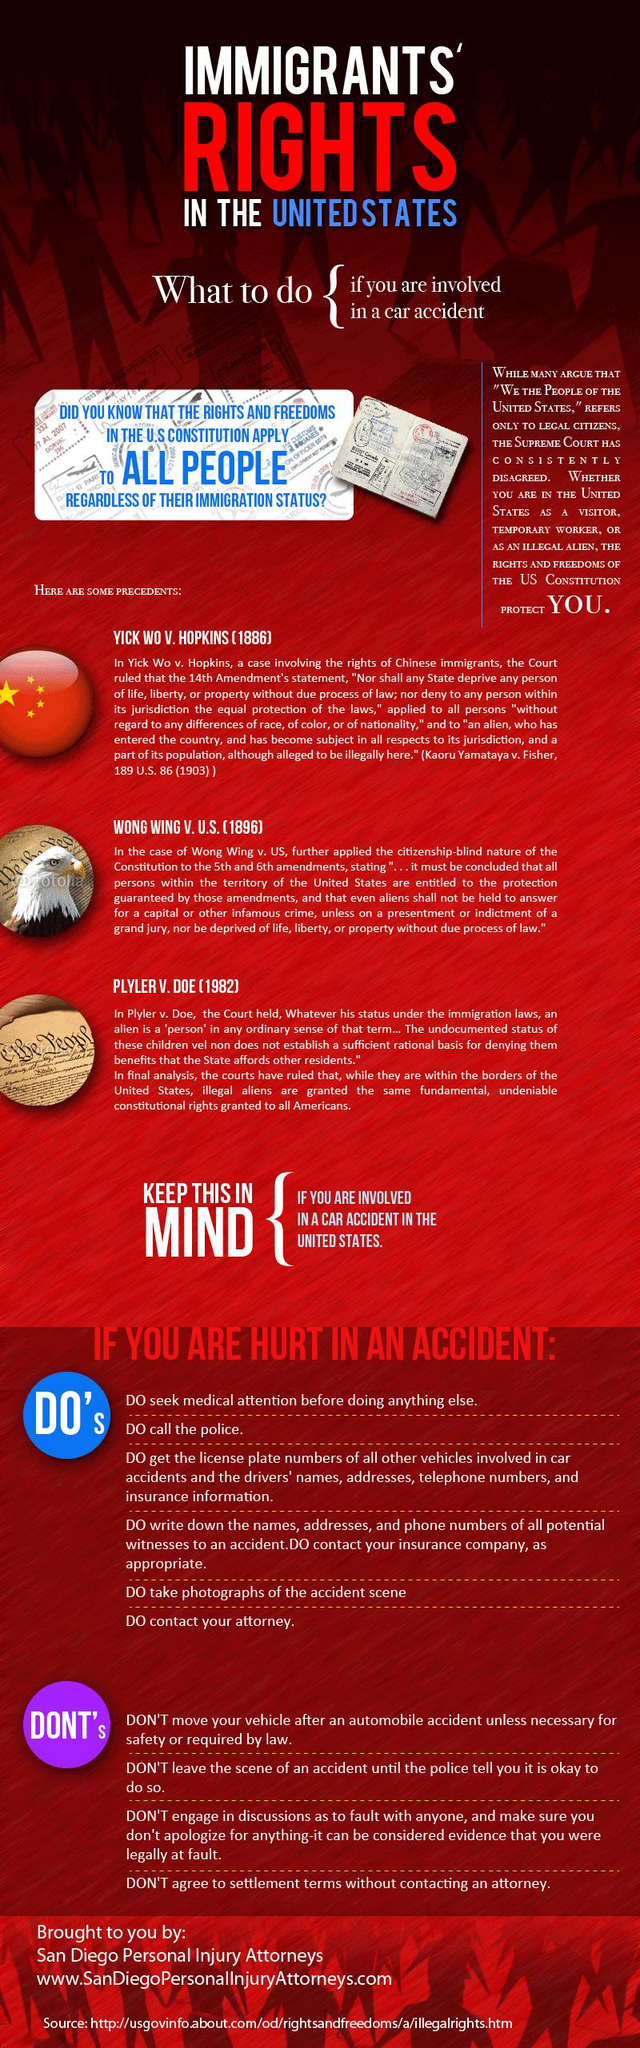Highlight a few significant elements in this photo. There are a total of 3 precedents listed. There are four Don'ts listed in the info graphic. There are six dos listed in the infographic. 